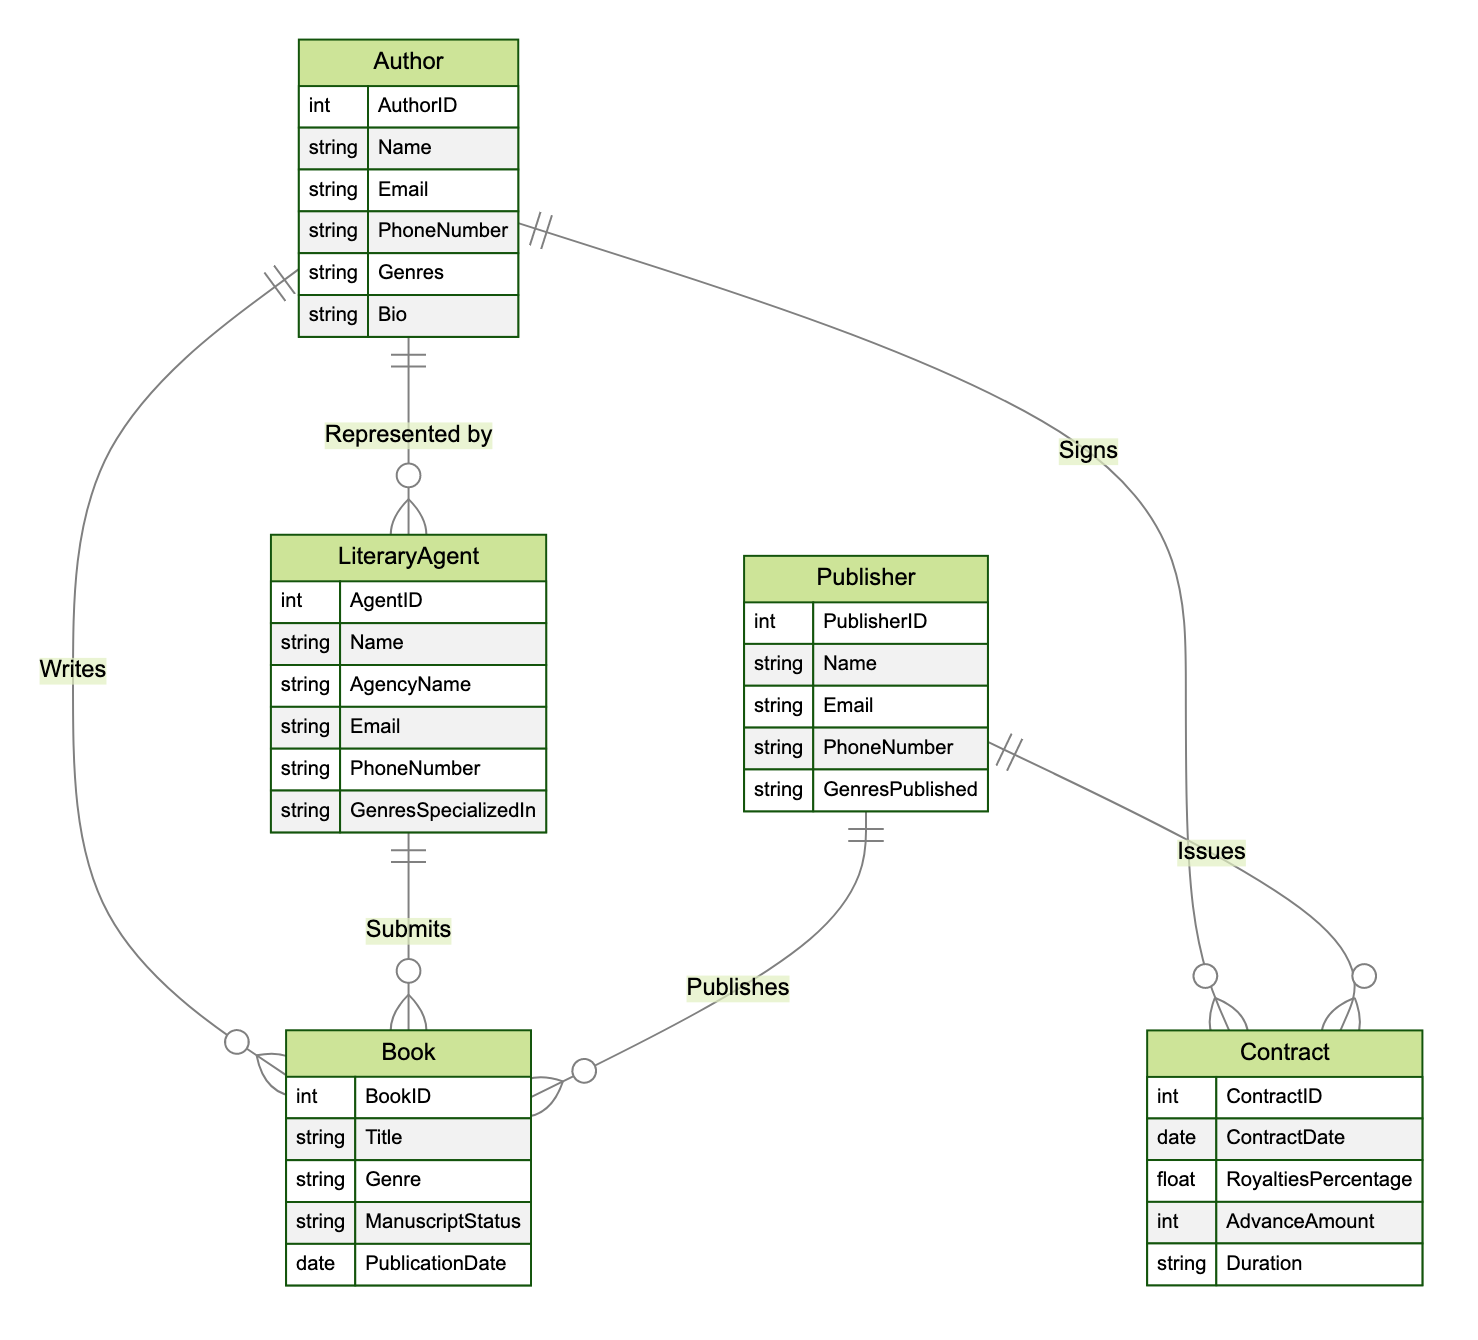what are the attributes of the Author entity? The Author entity lists the following attributes: AuthorID, Name, Email, PhoneNumber, Genres, and Bio. These are specified in the diagram under the Author entity section.
Answer: AuthorID, Name, Email, PhoneNumber, Genres, Bio how many entities are represented in the diagram? The diagram includes five distinct entities: Author, LiteraryAgent, Publisher, Book, and Contract. By counting these, we determine the total number of entities.
Answer: 5 what relationship exists between LiteraryAgent and Author? The relationship is named "Represents," indicating that a LiteraryAgent represents an Author. This can be seen directly in the relationship section of the diagram.
Answer: Represents what is the purpose of the Contracts relationship? The Contracts relationship connects both Publisher and Author, indicating how they engage in contracts concerning the publication. This is explicitly drawn in the relationship lines connecting these two entities.
Answer: Engagement in contracts how many attributes does the Book entity have? The Book entity includes five attributes: BookID, Title, Genre, ManuscriptStatus, and PublicationDate. Counting these attributes in the Book section confirms the total.
Answer: 5 what does the relationship “Publishes” indicate? The "Publishes" relationship signifies that a Publisher publishes a Book, implying the connection between these two entities regarding the publishing process. This is visually represented in the diagram by the relationship line and label.
Answer: Publisher publishes Book which entity has a relationship that allows for the signing of a contract? The Author entity has a relationship with the Contract entity, indicating that an Author can sign contracts. This can be inferred directly from the "Signs" relationship that connects these two entities.
Answer: Author what type of information does the ManuscriptStatus attribute in the Book entity represent? The ManuscriptStatus attribute indicates the current status of the manuscript for the Book entity, which could represent stages like "Submitted," "Accepted," or "Rejected." This is derived from its context within the diagram.
Answer: Current status of the manuscript 